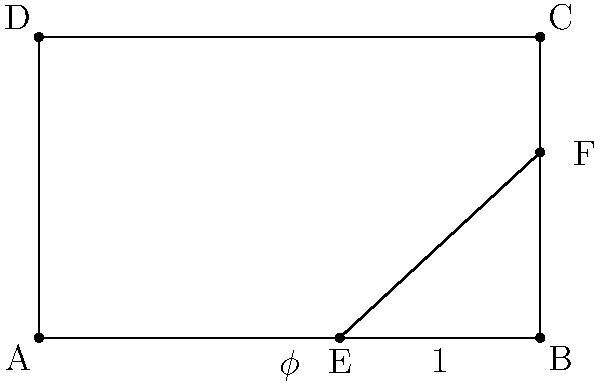In the given rectangle ABCD, point E divides AB in the golden ratio. If AE represents the longer segment of the golden ratio and EB the shorter segment, what is the ratio of the area of triangle AEF to the area of rectangle ABCD? Express your answer as a fraction in terms of $\phi$ (phi), the golden ratio. Let's approach this step-by-step:

1) The golden ratio $\phi$ is defined as: $\phi = \frac{a+b}{a} = \frac{a}{b}$, where $a$ is the longer segment and $b$ is the shorter segment.

2) In this case, $AE = \phi$ and $EB = 1$ (as given in the diagram).

3) The total length of AB is therefore $\phi + 1$.

4) The height of the rectangle is $\frac{AB}{\phi} = \frac{\phi + 1}{\phi}$.

5) The area of rectangle ABCD is:
   $$Area_{ABCD} = AB \times AD = (\phi + 1) \times \frac{\phi + 1}{\phi} = \frac{(\phi + 1)^2}{\phi}$$

6) For triangle AEF, we need to find its height. The ratio of this height to the rectangle's height is the same as the ratio of EB to AB:
   $$\frac{EF}{AD} = \frac{EB}{AB} = \frac{1}{\phi + 1}$$

7) So, $EF = \frac{\phi + 1}{\phi} \times \frac{1}{\phi + 1} = \frac{1}{\phi}$

8) The area of triangle AEF is:
   $$Area_{AEF} = \frac{1}{2} \times AE \times EF = \frac{1}{2} \times \phi \times \frac{1}{\phi} = \frac{1}{2}$$

9) The ratio of the areas is:
   $$\frac{Area_{AEF}}{Area_{ABCD}} = \frac{\frac{1}{2}}{\frac{(\phi + 1)^2}{\phi}} = \frac{\phi}{2(\phi + 1)^2}$$
Answer: $\frac{\phi}{2(\phi + 1)^2}$ 